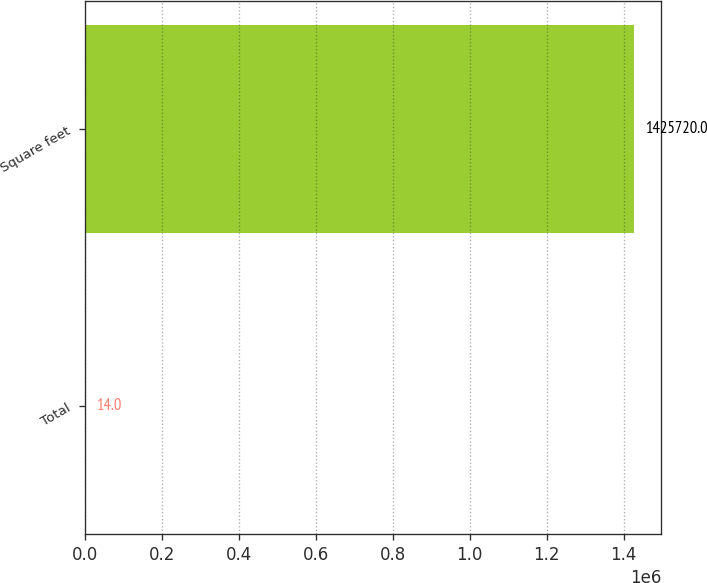Convert chart to OTSL. <chart><loc_0><loc_0><loc_500><loc_500><bar_chart><fcel>Total<fcel>Square feet<nl><fcel>14<fcel>1.42572e+06<nl></chart> 